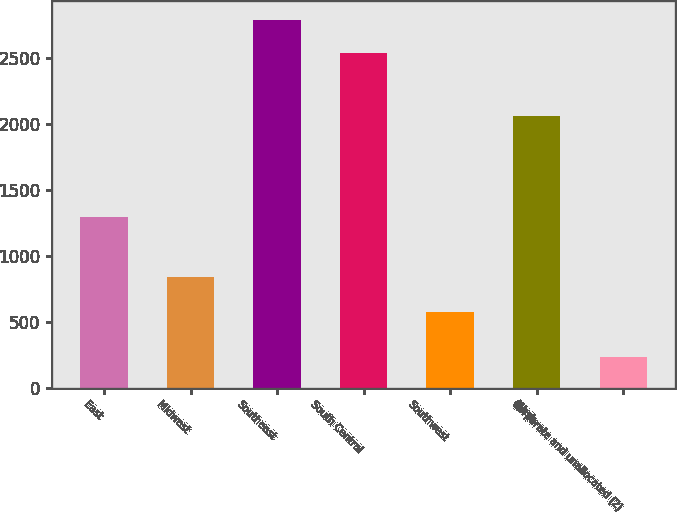<chart> <loc_0><loc_0><loc_500><loc_500><bar_chart><fcel>East<fcel>Midwest<fcel>Southeast<fcel>South Central<fcel>Southwest<fcel>West<fcel>Corporate and unallocated (2)<nl><fcel>1288.8<fcel>836.8<fcel>2787.16<fcel>2533.2<fcel>574.4<fcel>2056<fcel>228.4<nl></chart> 